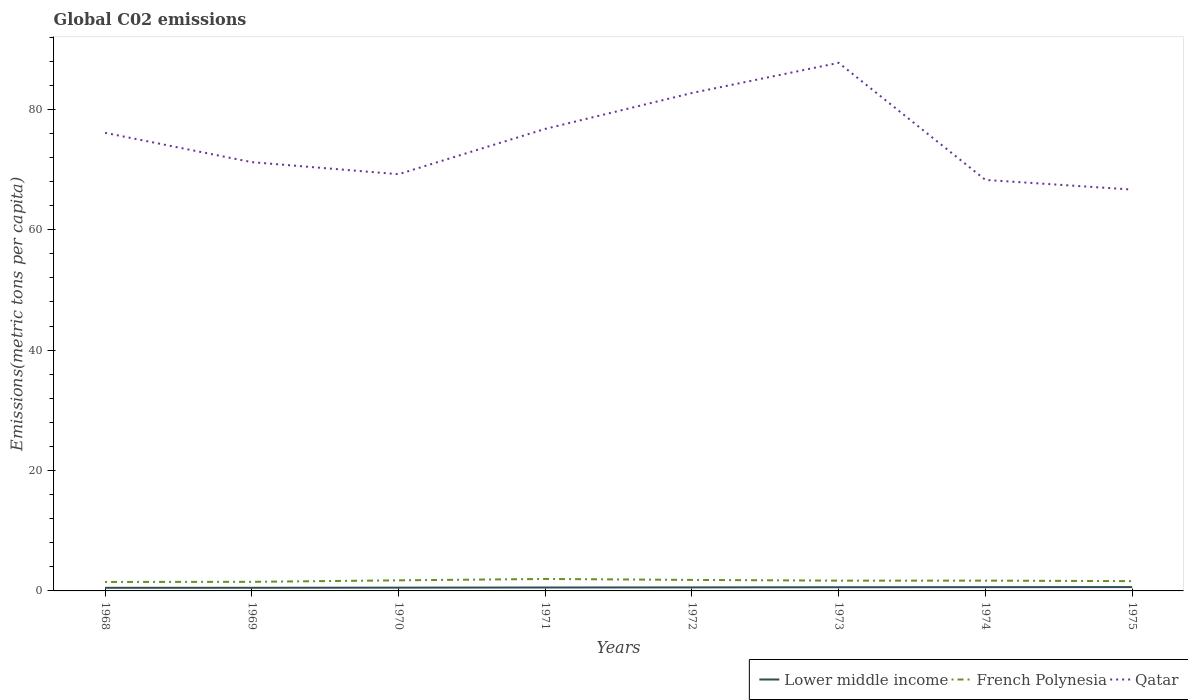Does the line corresponding to Qatar intersect with the line corresponding to Lower middle income?
Offer a terse response. No. Across all years, what is the maximum amount of CO2 emitted in in Qatar?
Make the answer very short. 66.68. In which year was the amount of CO2 emitted in in Qatar maximum?
Offer a very short reply. 1975. What is the total amount of CO2 emitted in in Lower middle income in the graph?
Keep it short and to the point. -0.04. What is the difference between the highest and the second highest amount of CO2 emitted in in French Polynesia?
Offer a very short reply. 0.5. Are the values on the major ticks of Y-axis written in scientific E-notation?
Give a very brief answer. No. Does the graph contain any zero values?
Your answer should be compact. No. How are the legend labels stacked?
Make the answer very short. Horizontal. What is the title of the graph?
Offer a very short reply. Global C02 emissions. What is the label or title of the Y-axis?
Ensure brevity in your answer.  Emissions(metric tons per capita). What is the Emissions(metric tons per capita) of Lower middle income in 1968?
Offer a very short reply. 0.52. What is the Emissions(metric tons per capita) of French Polynesia in 1968?
Keep it short and to the point. 1.49. What is the Emissions(metric tons per capita) in Qatar in 1968?
Your response must be concise. 76.1. What is the Emissions(metric tons per capita) of Lower middle income in 1969?
Offer a very short reply. 0.52. What is the Emissions(metric tons per capita) in French Polynesia in 1969?
Provide a short and direct response. 1.51. What is the Emissions(metric tons per capita) of Qatar in 1969?
Provide a short and direct response. 71.23. What is the Emissions(metric tons per capita) of Lower middle income in 1970?
Your answer should be compact. 0.54. What is the Emissions(metric tons per capita) of French Polynesia in 1970?
Provide a short and direct response. 1.76. What is the Emissions(metric tons per capita) of Qatar in 1970?
Keep it short and to the point. 69.23. What is the Emissions(metric tons per capita) of Lower middle income in 1971?
Your answer should be compact. 0.57. What is the Emissions(metric tons per capita) in French Polynesia in 1971?
Offer a very short reply. 1.99. What is the Emissions(metric tons per capita) of Qatar in 1971?
Provide a succinct answer. 76.76. What is the Emissions(metric tons per capita) in Lower middle income in 1972?
Your response must be concise. 0.58. What is the Emissions(metric tons per capita) in French Polynesia in 1972?
Make the answer very short. 1.83. What is the Emissions(metric tons per capita) of Qatar in 1972?
Offer a very short reply. 82.72. What is the Emissions(metric tons per capita) in Lower middle income in 1973?
Give a very brief answer. 0.61. What is the Emissions(metric tons per capita) in French Polynesia in 1973?
Your answer should be compact. 1.71. What is the Emissions(metric tons per capita) in Qatar in 1973?
Keep it short and to the point. 87.73. What is the Emissions(metric tons per capita) of Lower middle income in 1974?
Make the answer very short. 0.63. What is the Emissions(metric tons per capita) in French Polynesia in 1974?
Your answer should be very brief. 1.71. What is the Emissions(metric tons per capita) in Qatar in 1974?
Your answer should be very brief. 68.28. What is the Emissions(metric tons per capita) in Lower middle income in 1975?
Provide a short and direct response. 0.64. What is the Emissions(metric tons per capita) of French Polynesia in 1975?
Offer a very short reply. 1.63. What is the Emissions(metric tons per capita) in Qatar in 1975?
Provide a succinct answer. 66.68. Across all years, what is the maximum Emissions(metric tons per capita) of Lower middle income?
Your response must be concise. 0.64. Across all years, what is the maximum Emissions(metric tons per capita) of French Polynesia?
Offer a terse response. 1.99. Across all years, what is the maximum Emissions(metric tons per capita) of Qatar?
Your answer should be very brief. 87.73. Across all years, what is the minimum Emissions(metric tons per capita) in Lower middle income?
Make the answer very short. 0.52. Across all years, what is the minimum Emissions(metric tons per capita) in French Polynesia?
Your answer should be compact. 1.49. Across all years, what is the minimum Emissions(metric tons per capita) of Qatar?
Offer a terse response. 66.68. What is the total Emissions(metric tons per capita) of Lower middle income in the graph?
Provide a succinct answer. 4.61. What is the total Emissions(metric tons per capita) in French Polynesia in the graph?
Give a very brief answer. 13.62. What is the total Emissions(metric tons per capita) in Qatar in the graph?
Your response must be concise. 598.73. What is the difference between the Emissions(metric tons per capita) of Lower middle income in 1968 and that in 1969?
Keep it short and to the point. -0.01. What is the difference between the Emissions(metric tons per capita) in French Polynesia in 1968 and that in 1969?
Offer a very short reply. -0.02. What is the difference between the Emissions(metric tons per capita) in Qatar in 1968 and that in 1969?
Your answer should be very brief. 4.87. What is the difference between the Emissions(metric tons per capita) of Lower middle income in 1968 and that in 1970?
Give a very brief answer. -0.03. What is the difference between the Emissions(metric tons per capita) of French Polynesia in 1968 and that in 1970?
Give a very brief answer. -0.27. What is the difference between the Emissions(metric tons per capita) of Qatar in 1968 and that in 1970?
Make the answer very short. 6.88. What is the difference between the Emissions(metric tons per capita) in Lower middle income in 1968 and that in 1971?
Keep it short and to the point. -0.05. What is the difference between the Emissions(metric tons per capita) in French Polynesia in 1968 and that in 1971?
Offer a very short reply. -0.5. What is the difference between the Emissions(metric tons per capita) in Qatar in 1968 and that in 1971?
Keep it short and to the point. -0.65. What is the difference between the Emissions(metric tons per capita) of Lower middle income in 1968 and that in 1972?
Provide a short and direct response. -0.07. What is the difference between the Emissions(metric tons per capita) of French Polynesia in 1968 and that in 1972?
Provide a short and direct response. -0.34. What is the difference between the Emissions(metric tons per capita) in Qatar in 1968 and that in 1972?
Provide a succinct answer. -6.61. What is the difference between the Emissions(metric tons per capita) of Lower middle income in 1968 and that in 1973?
Make the answer very short. -0.09. What is the difference between the Emissions(metric tons per capita) of French Polynesia in 1968 and that in 1973?
Your response must be concise. -0.22. What is the difference between the Emissions(metric tons per capita) of Qatar in 1968 and that in 1973?
Keep it short and to the point. -11.63. What is the difference between the Emissions(metric tons per capita) of Lower middle income in 1968 and that in 1974?
Provide a short and direct response. -0.11. What is the difference between the Emissions(metric tons per capita) of French Polynesia in 1968 and that in 1974?
Offer a terse response. -0.22. What is the difference between the Emissions(metric tons per capita) in Qatar in 1968 and that in 1974?
Give a very brief answer. 7.82. What is the difference between the Emissions(metric tons per capita) of Lower middle income in 1968 and that in 1975?
Keep it short and to the point. -0.12. What is the difference between the Emissions(metric tons per capita) in French Polynesia in 1968 and that in 1975?
Keep it short and to the point. -0.14. What is the difference between the Emissions(metric tons per capita) of Qatar in 1968 and that in 1975?
Provide a succinct answer. 9.43. What is the difference between the Emissions(metric tons per capita) of Lower middle income in 1969 and that in 1970?
Your response must be concise. -0.02. What is the difference between the Emissions(metric tons per capita) in French Polynesia in 1969 and that in 1970?
Offer a terse response. -0.25. What is the difference between the Emissions(metric tons per capita) in Qatar in 1969 and that in 1970?
Keep it short and to the point. 2. What is the difference between the Emissions(metric tons per capita) in Lower middle income in 1969 and that in 1971?
Offer a very short reply. -0.05. What is the difference between the Emissions(metric tons per capita) of French Polynesia in 1969 and that in 1971?
Provide a short and direct response. -0.48. What is the difference between the Emissions(metric tons per capita) in Qatar in 1969 and that in 1971?
Your answer should be very brief. -5.53. What is the difference between the Emissions(metric tons per capita) in Lower middle income in 1969 and that in 1972?
Your answer should be very brief. -0.06. What is the difference between the Emissions(metric tons per capita) in French Polynesia in 1969 and that in 1972?
Provide a short and direct response. -0.32. What is the difference between the Emissions(metric tons per capita) in Qatar in 1969 and that in 1972?
Your response must be concise. -11.49. What is the difference between the Emissions(metric tons per capita) of Lower middle income in 1969 and that in 1973?
Give a very brief answer. -0.09. What is the difference between the Emissions(metric tons per capita) in French Polynesia in 1969 and that in 1973?
Your answer should be compact. -0.2. What is the difference between the Emissions(metric tons per capita) in Qatar in 1969 and that in 1973?
Ensure brevity in your answer.  -16.5. What is the difference between the Emissions(metric tons per capita) of Lower middle income in 1969 and that in 1974?
Provide a short and direct response. -0.1. What is the difference between the Emissions(metric tons per capita) in French Polynesia in 1969 and that in 1974?
Your answer should be very brief. -0.2. What is the difference between the Emissions(metric tons per capita) in Qatar in 1969 and that in 1974?
Provide a short and direct response. 2.95. What is the difference between the Emissions(metric tons per capita) of Lower middle income in 1969 and that in 1975?
Your answer should be compact. -0.11. What is the difference between the Emissions(metric tons per capita) of French Polynesia in 1969 and that in 1975?
Provide a short and direct response. -0.12. What is the difference between the Emissions(metric tons per capita) of Qatar in 1969 and that in 1975?
Your response must be concise. 4.55. What is the difference between the Emissions(metric tons per capita) in Lower middle income in 1970 and that in 1971?
Your answer should be compact. -0.02. What is the difference between the Emissions(metric tons per capita) in French Polynesia in 1970 and that in 1971?
Your answer should be compact. -0.23. What is the difference between the Emissions(metric tons per capita) of Qatar in 1970 and that in 1971?
Make the answer very short. -7.53. What is the difference between the Emissions(metric tons per capita) in Lower middle income in 1970 and that in 1972?
Provide a short and direct response. -0.04. What is the difference between the Emissions(metric tons per capita) in French Polynesia in 1970 and that in 1972?
Keep it short and to the point. -0.07. What is the difference between the Emissions(metric tons per capita) of Qatar in 1970 and that in 1972?
Your answer should be compact. -13.49. What is the difference between the Emissions(metric tons per capita) of Lower middle income in 1970 and that in 1973?
Provide a succinct answer. -0.07. What is the difference between the Emissions(metric tons per capita) in French Polynesia in 1970 and that in 1973?
Your answer should be very brief. 0.05. What is the difference between the Emissions(metric tons per capita) in Qatar in 1970 and that in 1973?
Keep it short and to the point. -18.5. What is the difference between the Emissions(metric tons per capita) in Lower middle income in 1970 and that in 1974?
Your answer should be very brief. -0.08. What is the difference between the Emissions(metric tons per capita) in French Polynesia in 1970 and that in 1974?
Your answer should be very brief. 0.05. What is the difference between the Emissions(metric tons per capita) of Qatar in 1970 and that in 1974?
Provide a short and direct response. 0.95. What is the difference between the Emissions(metric tons per capita) in Lower middle income in 1970 and that in 1975?
Provide a short and direct response. -0.09. What is the difference between the Emissions(metric tons per capita) in French Polynesia in 1970 and that in 1975?
Make the answer very short. 0.13. What is the difference between the Emissions(metric tons per capita) in Qatar in 1970 and that in 1975?
Make the answer very short. 2.55. What is the difference between the Emissions(metric tons per capita) of Lower middle income in 1971 and that in 1972?
Provide a succinct answer. -0.02. What is the difference between the Emissions(metric tons per capita) of French Polynesia in 1971 and that in 1972?
Your answer should be very brief. 0.16. What is the difference between the Emissions(metric tons per capita) in Qatar in 1971 and that in 1972?
Your answer should be compact. -5.96. What is the difference between the Emissions(metric tons per capita) of Lower middle income in 1971 and that in 1973?
Offer a very short reply. -0.04. What is the difference between the Emissions(metric tons per capita) in French Polynesia in 1971 and that in 1973?
Your answer should be very brief. 0.28. What is the difference between the Emissions(metric tons per capita) of Qatar in 1971 and that in 1973?
Make the answer very short. -10.98. What is the difference between the Emissions(metric tons per capita) of Lower middle income in 1971 and that in 1974?
Keep it short and to the point. -0.06. What is the difference between the Emissions(metric tons per capita) in French Polynesia in 1971 and that in 1974?
Offer a terse response. 0.28. What is the difference between the Emissions(metric tons per capita) of Qatar in 1971 and that in 1974?
Ensure brevity in your answer.  8.47. What is the difference between the Emissions(metric tons per capita) in Lower middle income in 1971 and that in 1975?
Provide a succinct answer. -0.07. What is the difference between the Emissions(metric tons per capita) in French Polynesia in 1971 and that in 1975?
Offer a terse response. 0.36. What is the difference between the Emissions(metric tons per capita) of Qatar in 1971 and that in 1975?
Your answer should be compact. 10.08. What is the difference between the Emissions(metric tons per capita) in Lower middle income in 1972 and that in 1973?
Give a very brief answer. -0.03. What is the difference between the Emissions(metric tons per capita) in French Polynesia in 1972 and that in 1973?
Provide a short and direct response. 0.12. What is the difference between the Emissions(metric tons per capita) in Qatar in 1972 and that in 1973?
Your answer should be very brief. -5.01. What is the difference between the Emissions(metric tons per capita) in Lower middle income in 1972 and that in 1974?
Make the answer very short. -0.04. What is the difference between the Emissions(metric tons per capita) of French Polynesia in 1972 and that in 1974?
Give a very brief answer. 0.12. What is the difference between the Emissions(metric tons per capita) of Qatar in 1972 and that in 1974?
Your answer should be compact. 14.44. What is the difference between the Emissions(metric tons per capita) of Lower middle income in 1972 and that in 1975?
Make the answer very short. -0.05. What is the difference between the Emissions(metric tons per capita) of French Polynesia in 1972 and that in 1975?
Offer a terse response. 0.2. What is the difference between the Emissions(metric tons per capita) of Qatar in 1972 and that in 1975?
Give a very brief answer. 16.04. What is the difference between the Emissions(metric tons per capita) of Lower middle income in 1973 and that in 1974?
Offer a very short reply. -0.02. What is the difference between the Emissions(metric tons per capita) of French Polynesia in 1973 and that in 1974?
Your answer should be compact. -0. What is the difference between the Emissions(metric tons per capita) of Qatar in 1973 and that in 1974?
Your response must be concise. 19.45. What is the difference between the Emissions(metric tons per capita) of Lower middle income in 1973 and that in 1975?
Provide a succinct answer. -0.03. What is the difference between the Emissions(metric tons per capita) of French Polynesia in 1973 and that in 1975?
Offer a terse response. 0.08. What is the difference between the Emissions(metric tons per capita) of Qatar in 1973 and that in 1975?
Make the answer very short. 21.06. What is the difference between the Emissions(metric tons per capita) in Lower middle income in 1974 and that in 1975?
Offer a very short reply. -0.01. What is the difference between the Emissions(metric tons per capita) in French Polynesia in 1974 and that in 1975?
Your answer should be compact. 0.08. What is the difference between the Emissions(metric tons per capita) of Qatar in 1974 and that in 1975?
Offer a very short reply. 1.61. What is the difference between the Emissions(metric tons per capita) in Lower middle income in 1968 and the Emissions(metric tons per capita) in French Polynesia in 1969?
Your answer should be compact. -0.99. What is the difference between the Emissions(metric tons per capita) in Lower middle income in 1968 and the Emissions(metric tons per capita) in Qatar in 1969?
Offer a very short reply. -70.71. What is the difference between the Emissions(metric tons per capita) in French Polynesia in 1968 and the Emissions(metric tons per capita) in Qatar in 1969?
Your answer should be compact. -69.74. What is the difference between the Emissions(metric tons per capita) in Lower middle income in 1968 and the Emissions(metric tons per capita) in French Polynesia in 1970?
Make the answer very short. -1.24. What is the difference between the Emissions(metric tons per capita) of Lower middle income in 1968 and the Emissions(metric tons per capita) of Qatar in 1970?
Make the answer very short. -68.71. What is the difference between the Emissions(metric tons per capita) in French Polynesia in 1968 and the Emissions(metric tons per capita) in Qatar in 1970?
Offer a very short reply. -67.74. What is the difference between the Emissions(metric tons per capita) in Lower middle income in 1968 and the Emissions(metric tons per capita) in French Polynesia in 1971?
Give a very brief answer. -1.47. What is the difference between the Emissions(metric tons per capita) in Lower middle income in 1968 and the Emissions(metric tons per capita) in Qatar in 1971?
Ensure brevity in your answer.  -76.24. What is the difference between the Emissions(metric tons per capita) in French Polynesia in 1968 and the Emissions(metric tons per capita) in Qatar in 1971?
Provide a succinct answer. -75.27. What is the difference between the Emissions(metric tons per capita) in Lower middle income in 1968 and the Emissions(metric tons per capita) in French Polynesia in 1972?
Make the answer very short. -1.31. What is the difference between the Emissions(metric tons per capita) in Lower middle income in 1968 and the Emissions(metric tons per capita) in Qatar in 1972?
Give a very brief answer. -82.2. What is the difference between the Emissions(metric tons per capita) in French Polynesia in 1968 and the Emissions(metric tons per capita) in Qatar in 1972?
Your answer should be compact. -81.23. What is the difference between the Emissions(metric tons per capita) in Lower middle income in 1968 and the Emissions(metric tons per capita) in French Polynesia in 1973?
Your answer should be compact. -1.19. What is the difference between the Emissions(metric tons per capita) in Lower middle income in 1968 and the Emissions(metric tons per capita) in Qatar in 1973?
Give a very brief answer. -87.22. What is the difference between the Emissions(metric tons per capita) of French Polynesia in 1968 and the Emissions(metric tons per capita) of Qatar in 1973?
Offer a terse response. -86.24. What is the difference between the Emissions(metric tons per capita) of Lower middle income in 1968 and the Emissions(metric tons per capita) of French Polynesia in 1974?
Ensure brevity in your answer.  -1.19. What is the difference between the Emissions(metric tons per capita) of Lower middle income in 1968 and the Emissions(metric tons per capita) of Qatar in 1974?
Give a very brief answer. -67.76. What is the difference between the Emissions(metric tons per capita) in French Polynesia in 1968 and the Emissions(metric tons per capita) in Qatar in 1974?
Your answer should be compact. -66.79. What is the difference between the Emissions(metric tons per capita) of Lower middle income in 1968 and the Emissions(metric tons per capita) of French Polynesia in 1975?
Your response must be concise. -1.11. What is the difference between the Emissions(metric tons per capita) of Lower middle income in 1968 and the Emissions(metric tons per capita) of Qatar in 1975?
Provide a succinct answer. -66.16. What is the difference between the Emissions(metric tons per capita) in French Polynesia in 1968 and the Emissions(metric tons per capita) in Qatar in 1975?
Your answer should be compact. -65.19. What is the difference between the Emissions(metric tons per capita) of Lower middle income in 1969 and the Emissions(metric tons per capita) of French Polynesia in 1970?
Provide a succinct answer. -1.24. What is the difference between the Emissions(metric tons per capita) in Lower middle income in 1969 and the Emissions(metric tons per capita) in Qatar in 1970?
Your response must be concise. -68.71. What is the difference between the Emissions(metric tons per capita) of French Polynesia in 1969 and the Emissions(metric tons per capita) of Qatar in 1970?
Make the answer very short. -67.72. What is the difference between the Emissions(metric tons per capita) in Lower middle income in 1969 and the Emissions(metric tons per capita) in French Polynesia in 1971?
Keep it short and to the point. -1.47. What is the difference between the Emissions(metric tons per capita) in Lower middle income in 1969 and the Emissions(metric tons per capita) in Qatar in 1971?
Provide a short and direct response. -76.23. What is the difference between the Emissions(metric tons per capita) in French Polynesia in 1969 and the Emissions(metric tons per capita) in Qatar in 1971?
Offer a very short reply. -75.25. What is the difference between the Emissions(metric tons per capita) of Lower middle income in 1969 and the Emissions(metric tons per capita) of French Polynesia in 1972?
Ensure brevity in your answer.  -1.31. What is the difference between the Emissions(metric tons per capita) in Lower middle income in 1969 and the Emissions(metric tons per capita) in Qatar in 1972?
Your answer should be compact. -82.2. What is the difference between the Emissions(metric tons per capita) in French Polynesia in 1969 and the Emissions(metric tons per capita) in Qatar in 1972?
Provide a succinct answer. -81.21. What is the difference between the Emissions(metric tons per capita) in Lower middle income in 1969 and the Emissions(metric tons per capita) in French Polynesia in 1973?
Your answer should be very brief. -1.19. What is the difference between the Emissions(metric tons per capita) of Lower middle income in 1969 and the Emissions(metric tons per capita) of Qatar in 1973?
Make the answer very short. -87.21. What is the difference between the Emissions(metric tons per capita) of French Polynesia in 1969 and the Emissions(metric tons per capita) of Qatar in 1973?
Your response must be concise. -86.22. What is the difference between the Emissions(metric tons per capita) in Lower middle income in 1969 and the Emissions(metric tons per capita) in French Polynesia in 1974?
Offer a terse response. -1.19. What is the difference between the Emissions(metric tons per capita) in Lower middle income in 1969 and the Emissions(metric tons per capita) in Qatar in 1974?
Give a very brief answer. -67.76. What is the difference between the Emissions(metric tons per capita) of French Polynesia in 1969 and the Emissions(metric tons per capita) of Qatar in 1974?
Your response must be concise. -66.77. What is the difference between the Emissions(metric tons per capita) in Lower middle income in 1969 and the Emissions(metric tons per capita) in French Polynesia in 1975?
Your answer should be compact. -1.11. What is the difference between the Emissions(metric tons per capita) in Lower middle income in 1969 and the Emissions(metric tons per capita) in Qatar in 1975?
Your answer should be very brief. -66.15. What is the difference between the Emissions(metric tons per capita) of French Polynesia in 1969 and the Emissions(metric tons per capita) of Qatar in 1975?
Keep it short and to the point. -65.17. What is the difference between the Emissions(metric tons per capita) of Lower middle income in 1970 and the Emissions(metric tons per capita) of French Polynesia in 1971?
Keep it short and to the point. -1.44. What is the difference between the Emissions(metric tons per capita) of Lower middle income in 1970 and the Emissions(metric tons per capita) of Qatar in 1971?
Ensure brevity in your answer.  -76.21. What is the difference between the Emissions(metric tons per capita) in French Polynesia in 1970 and the Emissions(metric tons per capita) in Qatar in 1971?
Keep it short and to the point. -75. What is the difference between the Emissions(metric tons per capita) in Lower middle income in 1970 and the Emissions(metric tons per capita) in French Polynesia in 1972?
Keep it short and to the point. -1.29. What is the difference between the Emissions(metric tons per capita) of Lower middle income in 1970 and the Emissions(metric tons per capita) of Qatar in 1972?
Your answer should be compact. -82.17. What is the difference between the Emissions(metric tons per capita) in French Polynesia in 1970 and the Emissions(metric tons per capita) in Qatar in 1972?
Make the answer very short. -80.96. What is the difference between the Emissions(metric tons per capita) of Lower middle income in 1970 and the Emissions(metric tons per capita) of French Polynesia in 1973?
Your response must be concise. -1.16. What is the difference between the Emissions(metric tons per capita) in Lower middle income in 1970 and the Emissions(metric tons per capita) in Qatar in 1973?
Your answer should be compact. -87.19. What is the difference between the Emissions(metric tons per capita) in French Polynesia in 1970 and the Emissions(metric tons per capita) in Qatar in 1973?
Your answer should be compact. -85.97. What is the difference between the Emissions(metric tons per capita) of Lower middle income in 1970 and the Emissions(metric tons per capita) of French Polynesia in 1974?
Provide a succinct answer. -1.17. What is the difference between the Emissions(metric tons per capita) of Lower middle income in 1970 and the Emissions(metric tons per capita) of Qatar in 1974?
Ensure brevity in your answer.  -67.74. What is the difference between the Emissions(metric tons per capita) in French Polynesia in 1970 and the Emissions(metric tons per capita) in Qatar in 1974?
Provide a short and direct response. -66.52. What is the difference between the Emissions(metric tons per capita) in Lower middle income in 1970 and the Emissions(metric tons per capita) in French Polynesia in 1975?
Provide a short and direct response. -1.08. What is the difference between the Emissions(metric tons per capita) of Lower middle income in 1970 and the Emissions(metric tons per capita) of Qatar in 1975?
Keep it short and to the point. -66.13. What is the difference between the Emissions(metric tons per capita) in French Polynesia in 1970 and the Emissions(metric tons per capita) in Qatar in 1975?
Your response must be concise. -64.92. What is the difference between the Emissions(metric tons per capita) of Lower middle income in 1971 and the Emissions(metric tons per capita) of French Polynesia in 1972?
Give a very brief answer. -1.26. What is the difference between the Emissions(metric tons per capita) in Lower middle income in 1971 and the Emissions(metric tons per capita) in Qatar in 1972?
Ensure brevity in your answer.  -82.15. What is the difference between the Emissions(metric tons per capita) of French Polynesia in 1971 and the Emissions(metric tons per capita) of Qatar in 1972?
Your answer should be very brief. -80.73. What is the difference between the Emissions(metric tons per capita) of Lower middle income in 1971 and the Emissions(metric tons per capita) of French Polynesia in 1973?
Give a very brief answer. -1.14. What is the difference between the Emissions(metric tons per capita) of Lower middle income in 1971 and the Emissions(metric tons per capita) of Qatar in 1973?
Your answer should be compact. -87.16. What is the difference between the Emissions(metric tons per capita) in French Polynesia in 1971 and the Emissions(metric tons per capita) in Qatar in 1973?
Keep it short and to the point. -85.74. What is the difference between the Emissions(metric tons per capita) of Lower middle income in 1971 and the Emissions(metric tons per capita) of French Polynesia in 1974?
Your answer should be very brief. -1.14. What is the difference between the Emissions(metric tons per capita) of Lower middle income in 1971 and the Emissions(metric tons per capita) of Qatar in 1974?
Provide a succinct answer. -67.71. What is the difference between the Emissions(metric tons per capita) of French Polynesia in 1971 and the Emissions(metric tons per capita) of Qatar in 1974?
Offer a terse response. -66.29. What is the difference between the Emissions(metric tons per capita) in Lower middle income in 1971 and the Emissions(metric tons per capita) in French Polynesia in 1975?
Your answer should be compact. -1.06. What is the difference between the Emissions(metric tons per capita) in Lower middle income in 1971 and the Emissions(metric tons per capita) in Qatar in 1975?
Provide a succinct answer. -66.11. What is the difference between the Emissions(metric tons per capita) of French Polynesia in 1971 and the Emissions(metric tons per capita) of Qatar in 1975?
Make the answer very short. -64.69. What is the difference between the Emissions(metric tons per capita) of Lower middle income in 1972 and the Emissions(metric tons per capita) of French Polynesia in 1973?
Make the answer very short. -1.12. What is the difference between the Emissions(metric tons per capita) of Lower middle income in 1972 and the Emissions(metric tons per capita) of Qatar in 1973?
Give a very brief answer. -87.15. What is the difference between the Emissions(metric tons per capita) of French Polynesia in 1972 and the Emissions(metric tons per capita) of Qatar in 1973?
Your response must be concise. -85.9. What is the difference between the Emissions(metric tons per capita) in Lower middle income in 1972 and the Emissions(metric tons per capita) in French Polynesia in 1974?
Provide a short and direct response. -1.13. What is the difference between the Emissions(metric tons per capita) in Lower middle income in 1972 and the Emissions(metric tons per capita) in Qatar in 1974?
Keep it short and to the point. -67.7. What is the difference between the Emissions(metric tons per capita) of French Polynesia in 1972 and the Emissions(metric tons per capita) of Qatar in 1974?
Provide a short and direct response. -66.45. What is the difference between the Emissions(metric tons per capita) of Lower middle income in 1972 and the Emissions(metric tons per capita) of French Polynesia in 1975?
Offer a terse response. -1.04. What is the difference between the Emissions(metric tons per capita) of Lower middle income in 1972 and the Emissions(metric tons per capita) of Qatar in 1975?
Offer a terse response. -66.09. What is the difference between the Emissions(metric tons per capita) of French Polynesia in 1972 and the Emissions(metric tons per capita) of Qatar in 1975?
Your response must be concise. -64.85. What is the difference between the Emissions(metric tons per capita) of Lower middle income in 1973 and the Emissions(metric tons per capita) of French Polynesia in 1974?
Your answer should be compact. -1.1. What is the difference between the Emissions(metric tons per capita) of Lower middle income in 1973 and the Emissions(metric tons per capita) of Qatar in 1974?
Give a very brief answer. -67.67. What is the difference between the Emissions(metric tons per capita) in French Polynesia in 1973 and the Emissions(metric tons per capita) in Qatar in 1974?
Offer a terse response. -66.57. What is the difference between the Emissions(metric tons per capita) of Lower middle income in 1973 and the Emissions(metric tons per capita) of French Polynesia in 1975?
Offer a very short reply. -1.02. What is the difference between the Emissions(metric tons per capita) in Lower middle income in 1973 and the Emissions(metric tons per capita) in Qatar in 1975?
Make the answer very short. -66.06. What is the difference between the Emissions(metric tons per capita) in French Polynesia in 1973 and the Emissions(metric tons per capita) in Qatar in 1975?
Make the answer very short. -64.97. What is the difference between the Emissions(metric tons per capita) in Lower middle income in 1974 and the Emissions(metric tons per capita) in French Polynesia in 1975?
Offer a very short reply. -1. What is the difference between the Emissions(metric tons per capita) of Lower middle income in 1974 and the Emissions(metric tons per capita) of Qatar in 1975?
Your response must be concise. -66.05. What is the difference between the Emissions(metric tons per capita) in French Polynesia in 1974 and the Emissions(metric tons per capita) in Qatar in 1975?
Ensure brevity in your answer.  -64.97. What is the average Emissions(metric tons per capita) in Lower middle income per year?
Keep it short and to the point. 0.58. What is the average Emissions(metric tons per capita) in French Polynesia per year?
Ensure brevity in your answer.  1.7. What is the average Emissions(metric tons per capita) of Qatar per year?
Offer a very short reply. 74.84. In the year 1968, what is the difference between the Emissions(metric tons per capita) in Lower middle income and Emissions(metric tons per capita) in French Polynesia?
Keep it short and to the point. -0.97. In the year 1968, what is the difference between the Emissions(metric tons per capita) in Lower middle income and Emissions(metric tons per capita) in Qatar?
Provide a succinct answer. -75.59. In the year 1968, what is the difference between the Emissions(metric tons per capita) in French Polynesia and Emissions(metric tons per capita) in Qatar?
Offer a terse response. -74.61. In the year 1969, what is the difference between the Emissions(metric tons per capita) of Lower middle income and Emissions(metric tons per capita) of French Polynesia?
Provide a succinct answer. -0.99. In the year 1969, what is the difference between the Emissions(metric tons per capita) of Lower middle income and Emissions(metric tons per capita) of Qatar?
Provide a short and direct response. -70.71. In the year 1969, what is the difference between the Emissions(metric tons per capita) in French Polynesia and Emissions(metric tons per capita) in Qatar?
Offer a very short reply. -69.72. In the year 1970, what is the difference between the Emissions(metric tons per capita) of Lower middle income and Emissions(metric tons per capita) of French Polynesia?
Offer a terse response. -1.21. In the year 1970, what is the difference between the Emissions(metric tons per capita) of Lower middle income and Emissions(metric tons per capita) of Qatar?
Your answer should be compact. -68.68. In the year 1970, what is the difference between the Emissions(metric tons per capita) in French Polynesia and Emissions(metric tons per capita) in Qatar?
Your answer should be very brief. -67.47. In the year 1971, what is the difference between the Emissions(metric tons per capita) of Lower middle income and Emissions(metric tons per capita) of French Polynesia?
Give a very brief answer. -1.42. In the year 1971, what is the difference between the Emissions(metric tons per capita) in Lower middle income and Emissions(metric tons per capita) in Qatar?
Keep it short and to the point. -76.19. In the year 1971, what is the difference between the Emissions(metric tons per capita) of French Polynesia and Emissions(metric tons per capita) of Qatar?
Offer a very short reply. -74.77. In the year 1972, what is the difference between the Emissions(metric tons per capita) in Lower middle income and Emissions(metric tons per capita) in French Polynesia?
Provide a succinct answer. -1.24. In the year 1972, what is the difference between the Emissions(metric tons per capita) of Lower middle income and Emissions(metric tons per capita) of Qatar?
Give a very brief answer. -82.13. In the year 1972, what is the difference between the Emissions(metric tons per capita) in French Polynesia and Emissions(metric tons per capita) in Qatar?
Your response must be concise. -80.89. In the year 1973, what is the difference between the Emissions(metric tons per capita) in Lower middle income and Emissions(metric tons per capita) in French Polynesia?
Make the answer very short. -1.1. In the year 1973, what is the difference between the Emissions(metric tons per capita) in Lower middle income and Emissions(metric tons per capita) in Qatar?
Your answer should be very brief. -87.12. In the year 1973, what is the difference between the Emissions(metric tons per capita) in French Polynesia and Emissions(metric tons per capita) in Qatar?
Offer a terse response. -86.02. In the year 1974, what is the difference between the Emissions(metric tons per capita) in Lower middle income and Emissions(metric tons per capita) in French Polynesia?
Make the answer very short. -1.08. In the year 1974, what is the difference between the Emissions(metric tons per capita) in Lower middle income and Emissions(metric tons per capita) in Qatar?
Keep it short and to the point. -67.66. In the year 1974, what is the difference between the Emissions(metric tons per capita) of French Polynesia and Emissions(metric tons per capita) of Qatar?
Give a very brief answer. -66.57. In the year 1975, what is the difference between the Emissions(metric tons per capita) of Lower middle income and Emissions(metric tons per capita) of French Polynesia?
Offer a very short reply. -0.99. In the year 1975, what is the difference between the Emissions(metric tons per capita) of Lower middle income and Emissions(metric tons per capita) of Qatar?
Offer a terse response. -66.04. In the year 1975, what is the difference between the Emissions(metric tons per capita) of French Polynesia and Emissions(metric tons per capita) of Qatar?
Offer a very short reply. -65.05. What is the ratio of the Emissions(metric tons per capita) of Lower middle income in 1968 to that in 1969?
Keep it short and to the point. 0.99. What is the ratio of the Emissions(metric tons per capita) of French Polynesia in 1968 to that in 1969?
Give a very brief answer. 0.99. What is the ratio of the Emissions(metric tons per capita) in Qatar in 1968 to that in 1969?
Provide a short and direct response. 1.07. What is the ratio of the Emissions(metric tons per capita) of Lower middle income in 1968 to that in 1970?
Offer a very short reply. 0.95. What is the ratio of the Emissions(metric tons per capita) of French Polynesia in 1968 to that in 1970?
Ensure brevity in your answer.  0.85. What is the ratio of the Emissions(metric tons per capita) in Qatar in 1968 to that in 1970?
Ensure brevity in your answer.  1.1. What is the ratio of the Emissions(metric tons per capita) of Lower middle income in 1968 to that in 1971?
Your answer should be compact. 0.91. What is the ratio of the Emissions(metric tons per capita) in French Polynesia in 1968 to that in 1971?
Keep it short and to the point. 0.75. What is the ratio of the Emissions(metric tons per capita) of Lower middle income in 1968 to that in 1972?
Keep it short and to the point. 0.89. What is the ratio of the Emissions(metric tons per capita) of French Polynesia in 1968 to that in 1972?
Provide a short and direct response. 0.81. What is the ratio of the Emissions(metric tons per capita) in Lower middle income in 1968 to that in 1973?
Give a very brief answer. 0.85. What is the ratio of the Emissions(metric tons per capita) of French Polynesia in 1968 to that in 1973?
Keep it short and to the point. 0.87. What is the ratio of the Emissions(metric tons per capita) in Qatar in 1968 to that in 1973?
Ensure brevity in your answer.  0.87. What is the ratio of the Emissions(metric tons per capita) in Lower middle income in 1968 to that in 1974?
Keep it short and to the point. 0.83. What is the ratio of the Emissions(metric tons per capita) in French Polynesia in 1968 to that in 1974?
Your answer should be compact. 0.87. What is the ratio of the Emissions(metric tons per capita) in Qatar in 1968 to that in 1974?
Ensure brevity in your answer.  1.11. What is the ratio of the Emissions(metric tons per capita) in Lower middle income in 1968 to that in 1975?
Provide a succinct answer. 0.81. What is the ratio of the Emissions(metric tons per capita) of French Polynesia in 1968 to that in 1975?
Keep it short and to the point. 0.91. What is the ratio of the Emissions(metric tons per capita) in Qatar in 1968 to that in 1975?
Give a very brief answer. 1.14. What is the ratio of the Emissions(metric tons per capita) in Lower middle income in 1969 to that in 1970?
Make the answer very short. 0.96. What is the ratio of the Emissions(metric tons per capita) of French Polynesia in 1969 to that in 1970?
Make the answer very short. 0.86. What is the ratio of the Emissions(metric tons per capita) in Qatar in 1969 to that in 1970?
Give a very brief answer. 1.03. What is the ratio of the Emissions(metric tons per capita) of French Polynesia in 1969 to that in 1971?
Provide a short and direct response. 0.76. What is the ratio of the Emissions(metric tons per capita) of Qatar in 1969 to that in 1971?
Offer a very short reply. 0.93. What is the ratio of the Emissions(metric tons per capita) of Lower middle income in 1969 to that in 1972?
Offer a terse response. 0.89. What is the ratio of the Emissions(metric tons per capita) of French Polynesia in 1969 to that in 1972?
Keep it short and to the point. 0.83. What is the ratio of the Emissions(metric tons per capita) of Qatar in 1969 to that in 1972?
Offer a very short reply. 0.86. What is the ratio of the Emissions(metric tons per capita) of Lower middle income in 1969 to that in 1973?
Your answer should be compact. 0.86. What is the ratio of the Emissions(metric tons per capita) of French Polynesia in 1969 to that in 1973?
Your answer should be very brief. 0.88. What is the ratio of the Emissions(metric tons per capita) of Qatar in 1969 to that in 1973?
Your response must be concise. 0.81. What is the ratio of the Emissions(metric tons per capita) in Lower middle income in 1969 to that in 1974?
Your answer should be compact. 0.83. What is the ratio of the Emissions(metric tons per capita) of French Polynesia in 1969 to that in 1974?
Offer a very short reply. 0.88. What is the ratio of the Emissions(metric tons per capita) of Qatar in 1969 to that in 1974?
Provide a succinct answer. 1.04. What is the ratio of the Emissions(metric tons per capita) of Lower middle income in 1969 to that in 1975?
Offer a very short reply. 0.82. What is the ratio of the Emissions(metric tons per capita) of French Polynesia in 1969 to that in 1975?
Your answer should be compact. 0.93. What is the ratio of the Emissions(metric tons per capita) in Qatar in 1969 to that in 1975?
Your answer should be very brief. 1.07. What is the ratio of the Emissions(metric tons per capita) in Lower middle income in 1970 to that in 1971?
Offer a terse response. 0.96. What is the ratio of the Emissions(metric tons per capita) of French Polynesia in 1970 to that in 1971?
Offer a terse response. 0.88. What is the ratio of the Emissions(metric tons per capita) in Qatar in 1970 to that in 1971?
Provide a short and direct response. 0.9. What is the ratio of the Emissions(metric tons per capita) in Lower middle income in 1970 to that in 1972?
Your answer should be very brief. 0.93. What is the ratio of the Emissions(metric tons per capita) of French Polynesia in 1970 to that in 1972?
Your answer should be very brief. 0.96. What is the ratio of the Emissions(metric tons per capita) of Qatar in 1970 to that in 1972?
Give a very brief answer. 0.84. What is the ratio of the Emissions(metric tons per capita) of Lower middle income in 1970 to that in 1973?
Your response must be concise. 0.89. What is the ratio of the Emissions(metric tons per capita) of French Polynesia in 1970 to that in 1973?
Your answer should be very brief. 1.03. What is the ratio of the Emissions(metric tons per capita) of Qatar in 1970 to that in 1973?
Provide a succinct answer. 0.79. What is the ratio of the Emissions(metric tons per capita) in Lower middle income in 1970 to that in 1974?
Offer a very short reply. 0.87. What is the ratio of the Emissions(metric tons per capita) in French Polynesia in 1970 to that in 1974?
Keep it short and to the point. 1.03. What is the ratio of the Emissions(metric tons per capita) of Qatar in 1970 to that in 1974?
Your answer should be very brief. 1.01. What is the ratio of the Emissions(metric tons per capita) of Lower middle income in 1970 to that in 1975?
Provide a succinct answer. 0.85. What is the ratio of the Emissions(metric tons per capita) of French Polynesia in 1970 to that in 1975?
Give a very brief answer. 1.08. What is the ratio of the Emissions(metric tons per capita) of Qatar in 1970 to that in 1975?
Your answer should be compact. 1.04. What is the ratio of the Emissions(metric tons per capita) in Lower middle income in 1971 to that in 1972?
Give a very brief answer. 0.97. What is the ratio of the Emissions(metric tons per capita) in French Polynesia in 1971 to that in 1972?
Provide a succinct answer. 1.09. What is the ratio of the Emissions(metric tons per capita) in Qatar in 1971 to that in 1972?
Your answer should be compact. 0.93. What is the ratio of the Emissions(metric tons per capita) of Lower middle income in 1971 to that in 1973?
Offer a terse response. 0.93. What is the ratio of the Emissions(metric tons per capita) in French Polynesia in 1971 to that in 1973?
Offer a very short reply. 1.16. What is the ratio of the Emissions(metric tons per capita) in Qatar in 1971 to that in 1973?
Provide a succinct answer. 0.87. What is the ratio of the Emissions(metric tons per capita) of Lower middle income in 1971 to that in 1974?
Make the answer very short. 0.91. What is the ratio of the Emissions(metric tons per capita) in French Polynesia in 1971 to that in 1974?
Offer a terse response. 1.16. What is the ratio of the Emissions(metric tons per capita) of Qatar in 1971 to that in 1974?
Your response must be concise. 1.12. What is the ratio of the Emissions(metric tons per capita) in Lower middle income in 1971 to that in 1975?
Your answer should be very brief. 0.89. What is the ratio of the Emissions(metric tons per capita) in French Polynesia in 1971 to that in 1975?
Provide a succinct answer. 1.22. What is the ratio of the Emissions(metric tons per capita) of Qatar in 1971 to that in 1975?
Offer a terse response. 1.15. What is the ratio of the Emissions(metric tons per capita) in Lower middle income in 1972 to that in 1973?
Give a very brief answer. 0.96. What is the ratio of the Emissions(metric tons per capita) in French Polynesia in 1972 to that in 1973?
Your answer should be compact. 1.07. What is the ratio of the Emissions(metric tons per capita) of Qatar in 1972 to that in 1973?
Your answer should be very brief. 0.94. What is the ratio of the Emissions(metric tons per capita) in Lower middle income in 1972 to that in 1974?
Your answer should be compact. 0.93. What is the ratio of the Emissions(metric tons per capita) of French Polynesia in 1972 to that in 1974?
Your answer should be compact. 1.07. What is the ratio of the Emissions(metric tons per capita) in Qatar in 1972 to that in 1974?
Offer a terse response. 1.21. What is the ratio of the Emissions(metric tons per capita) in Lower middle income in 1972 to that in 1975?
Ensure brevity in your answer.  0.92. What is the ratio of the Emissions(metric tons per capita) in French Polynesia in 1972 to that in 1975?
Offer a terse response. 1.12. What is the ratio of the Emissions(metric tons per capita) of Qatar in 1972 to that in 1975?
Your answer should be very brief. 1.24. What is the ratio of the Emissions(metric tons per capita) of Lower middle income in 1973 to that in 1974?
Make the answer very short. 0.98. What is the ratio of the Emissions(metric tons per capita) of Qatar in 1973 to that in 1974?
Keep it short and to the point. 1.28. What is the ratio of the Emissions(metric tons per capita) in Lower middle income in 1973 to that in 1975?
Offer a terse response. 0.96. What is the ratio of the Emissions(metric tons per capita) of French Polynesia in 1973 to that in 1975?
Provide a short and direct response. 1.05. What is the ratio of the Emissions(metric tons per capita) of Qatar in 1973 to that in 1975?
Offer a terse response. 1.32. What is the ratio of the Emissions(metric tons per capita) of Lower middle income in 1974 to that in 1975?
Provide a short and direct response. 0.98. What is the ratio of the Emissions(metric tons per capita) in French Polynesia in 1974 to that in 1975?
Keep it short and to the point. 1.05. What is the ratio of the Emissions(metric tons per capita) in Qatar in 1974 to that in 1975?
Keep it short and to the point. 1.02. What is the difference between the highest and the second highest Emissions(metric tons per capita) in Lower middle income?
Your answer should be very brief. 0.01. What is the difference between the highest and the second highest Emissions(metric tons per capita) of French Polynesia?
Your response must be concise. 0.16. What is the difference between the highest and the second highest Emissions(metric tons per capita) of Qatar?
Give a very brief answer. 5.01. What is the difference between the highest and the lowest Emissions(metric tons per capita) in Lower middle income?
Provide a succinct answer. 0.12. What is the difference between the highest and the lowest Emissions(metric tons per capita) in French Polynesia?
Provide a succinct answer. 0.5. What is the difference between the highest and the lowest Emissions(metric tons per capita) of Qatar?
Your answer should be compact. 21.06. 